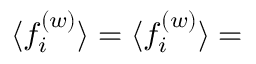<formula> <loc_0><loc_0><loc_500><loc_500>\langle f _ { i } ^ { ( w ) } \rangle = \langle f _ { i } ^ { ( w ) } \rangle =</formula> 